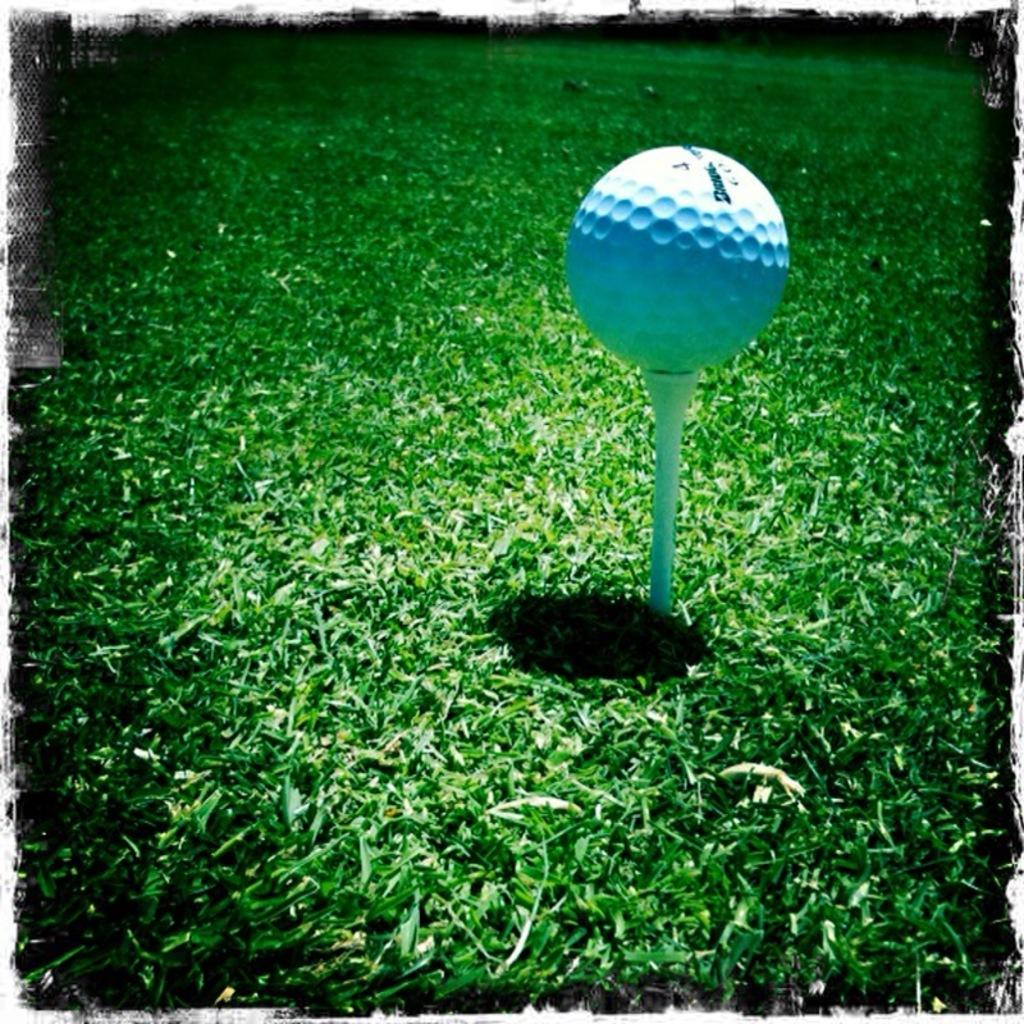What object is the main focus of the image? There is a golf ball in the image. What color is the golf ball? The golf ball is white in color. Where is the golf ball located? The golf ball is placed in a garden. What is the color of the grass in the background? The grass is green in color. Can you see a nest in the image? There is no nest present in the image. What type of ink is used to write on the golf ball? There is no writing on the golf ball, so the type of ink is not relevant. 